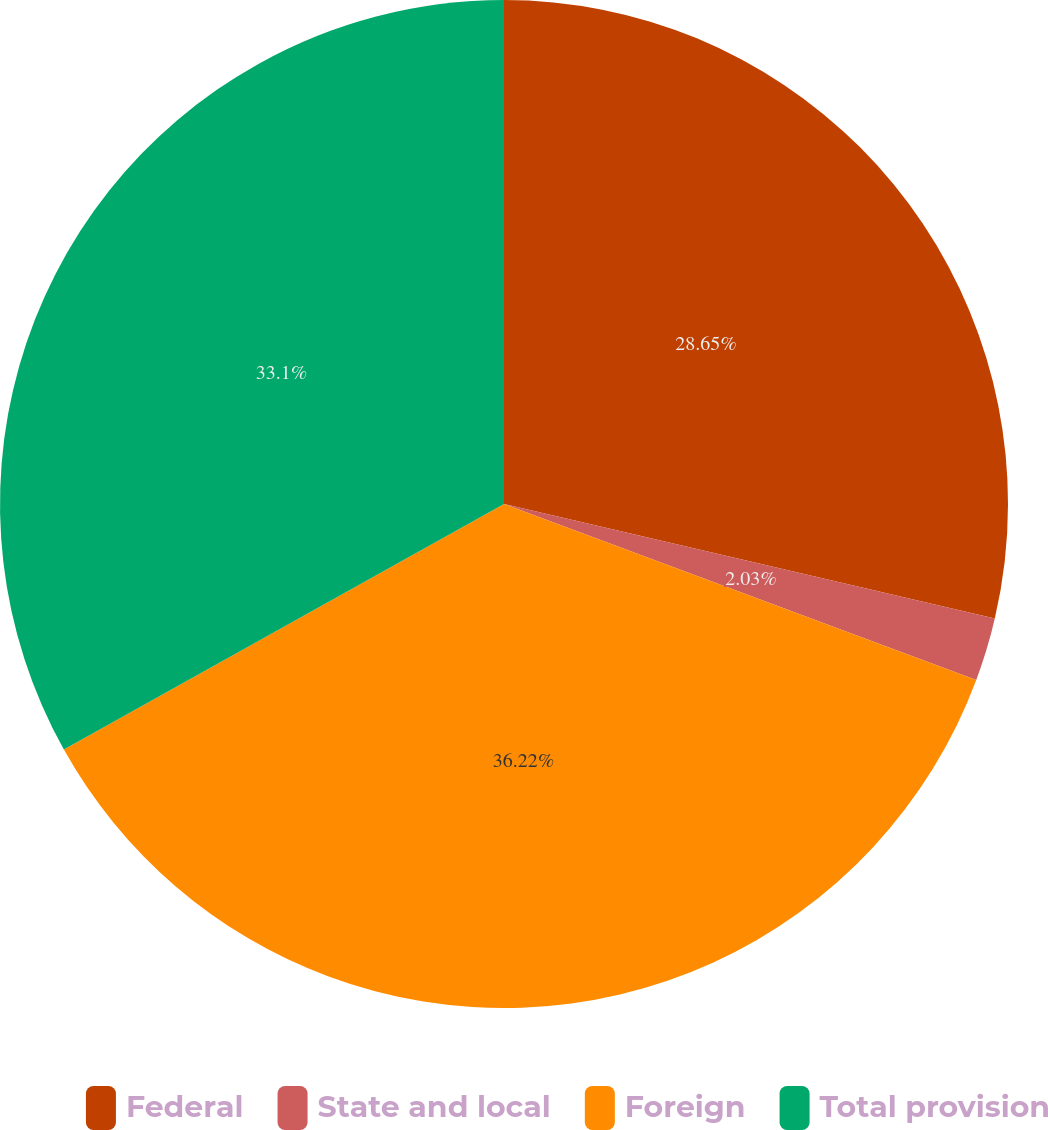Convert chart to OTSL. <chart><loc_0><loc_0><loc_500><loc_500><pie_chart><fcel>Federal<fcel>State and local<fcel>Foreign<fcel>Total provision<nl><fcel>28.65%<fcel>2.03%<fcel>36.22%<fcel>33.1%<nl></chart> 